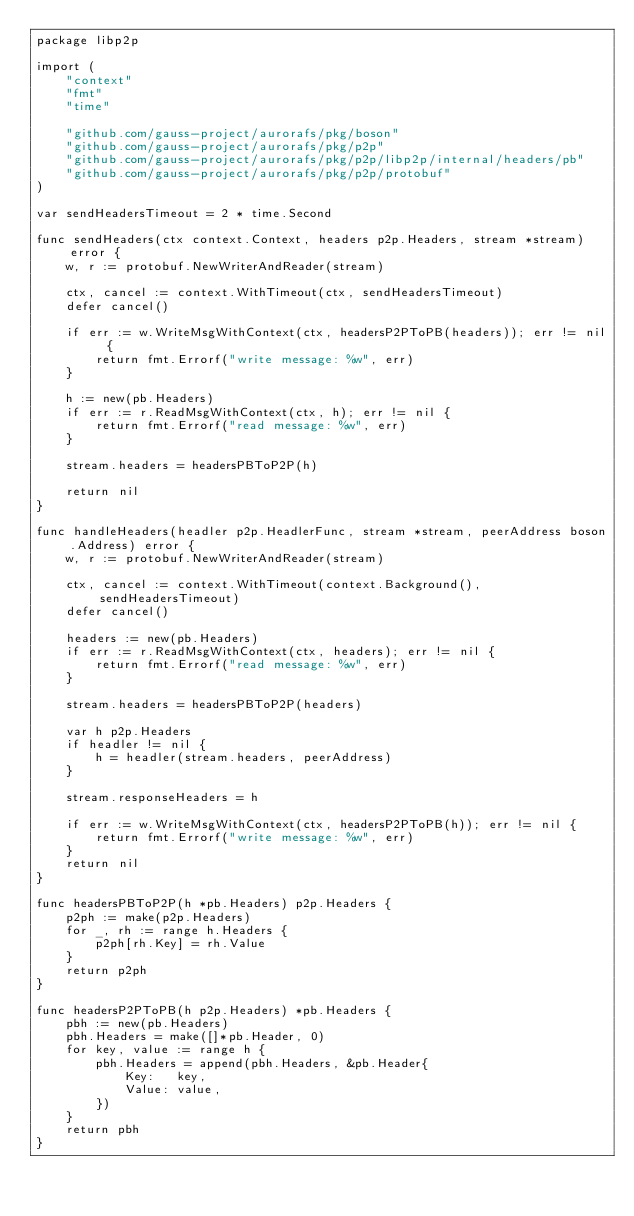Convert code to text. <code><loc_0><loc_0><loc_500><loc_500><_Go_>package libp2p

import (
	"context"
	"fmt"
	"time"

	"github.com/gauss-project/aurorafs/pkg/boson"
	"github.com/gauss-project/aurorafs/pkg/p2p"
	"github.com/gauss-project/aurorafs/pkg/p2p/libp2p/internal/headers/pb"
	"github.com/gauss-project/aurorafs/pkg/p2p/protobuf"
)

var sendHeadersTimeout = 2 * time.Second

func sendHeaders(ctx context.Context, headers p2p.Headers, stream *stream) error {
	w, r := protobuf.NewWriterAndReader(stream)

	ctx, cancel := context.WithTimeout(ctx, sendHeadersTimeout)
	defer cancel()

	if err := w.WriteMsgWithContext(ctx, headersP2PToPB(headers)); err != nil {
		return fmt.Errorf("write message: %w", err)
	}

	h := new(pb.Headers)
	if err := r.ReadMsgWithContext(ctx, h); err != nil {
		return fmt.Errorf("read message: %w", err)
	}

	stream.headers = headersPBToP2P(h)

	return nil
}

func handleHeaders(headler p2p.HeadlerFunc, stream *stream, peerAddress boson.Address) error {
	w, r := protobuf.NewWriterAndReader(stream)

	ctx, cancel := context.WithTimeout(context.Background(), sendHeadersTimeout)
	defer cancel()

	headers := new(pb.Headers)
	if err := r.ReadMsgWithContext(ctx, headers); err != nil {
		return fmt.Errorf("read message: %w", err)
	}

	stream.headers = headersPBToP2P(headers)

	var h p2p.Headers
	if headler != nil {
		h = headler(stream.headers, peerAddress)
	}

	stream.responseHeaders = h

	if err := w.WriteMsgWithContext(ctx, headersP2PToPB(h)); err != nil {
		return fmt.Errorf("write message: %w", err)
	}
	return nil
}

func headersPBToP2P(h *pb.Headers) p2p.Headers {
	p2ph := make(p2p.Headers)
	for _, rh := range h.Headers {
		p2ph[rh.Key] = rh.Value
	}
	return p2ph
}

func headersP2PToPB(h p2p.Headers) *pb.Headers {
	pbh := new(pb.Headers)
	pbh.Headers = make([]*pb.Header, 0)
	for key, value := range h {
		pbh.Headers = append(pbh.Headers, &pb.Header{
			Key:   key,
			Value: value,
		})
	}
	return pbh
}
</code> 